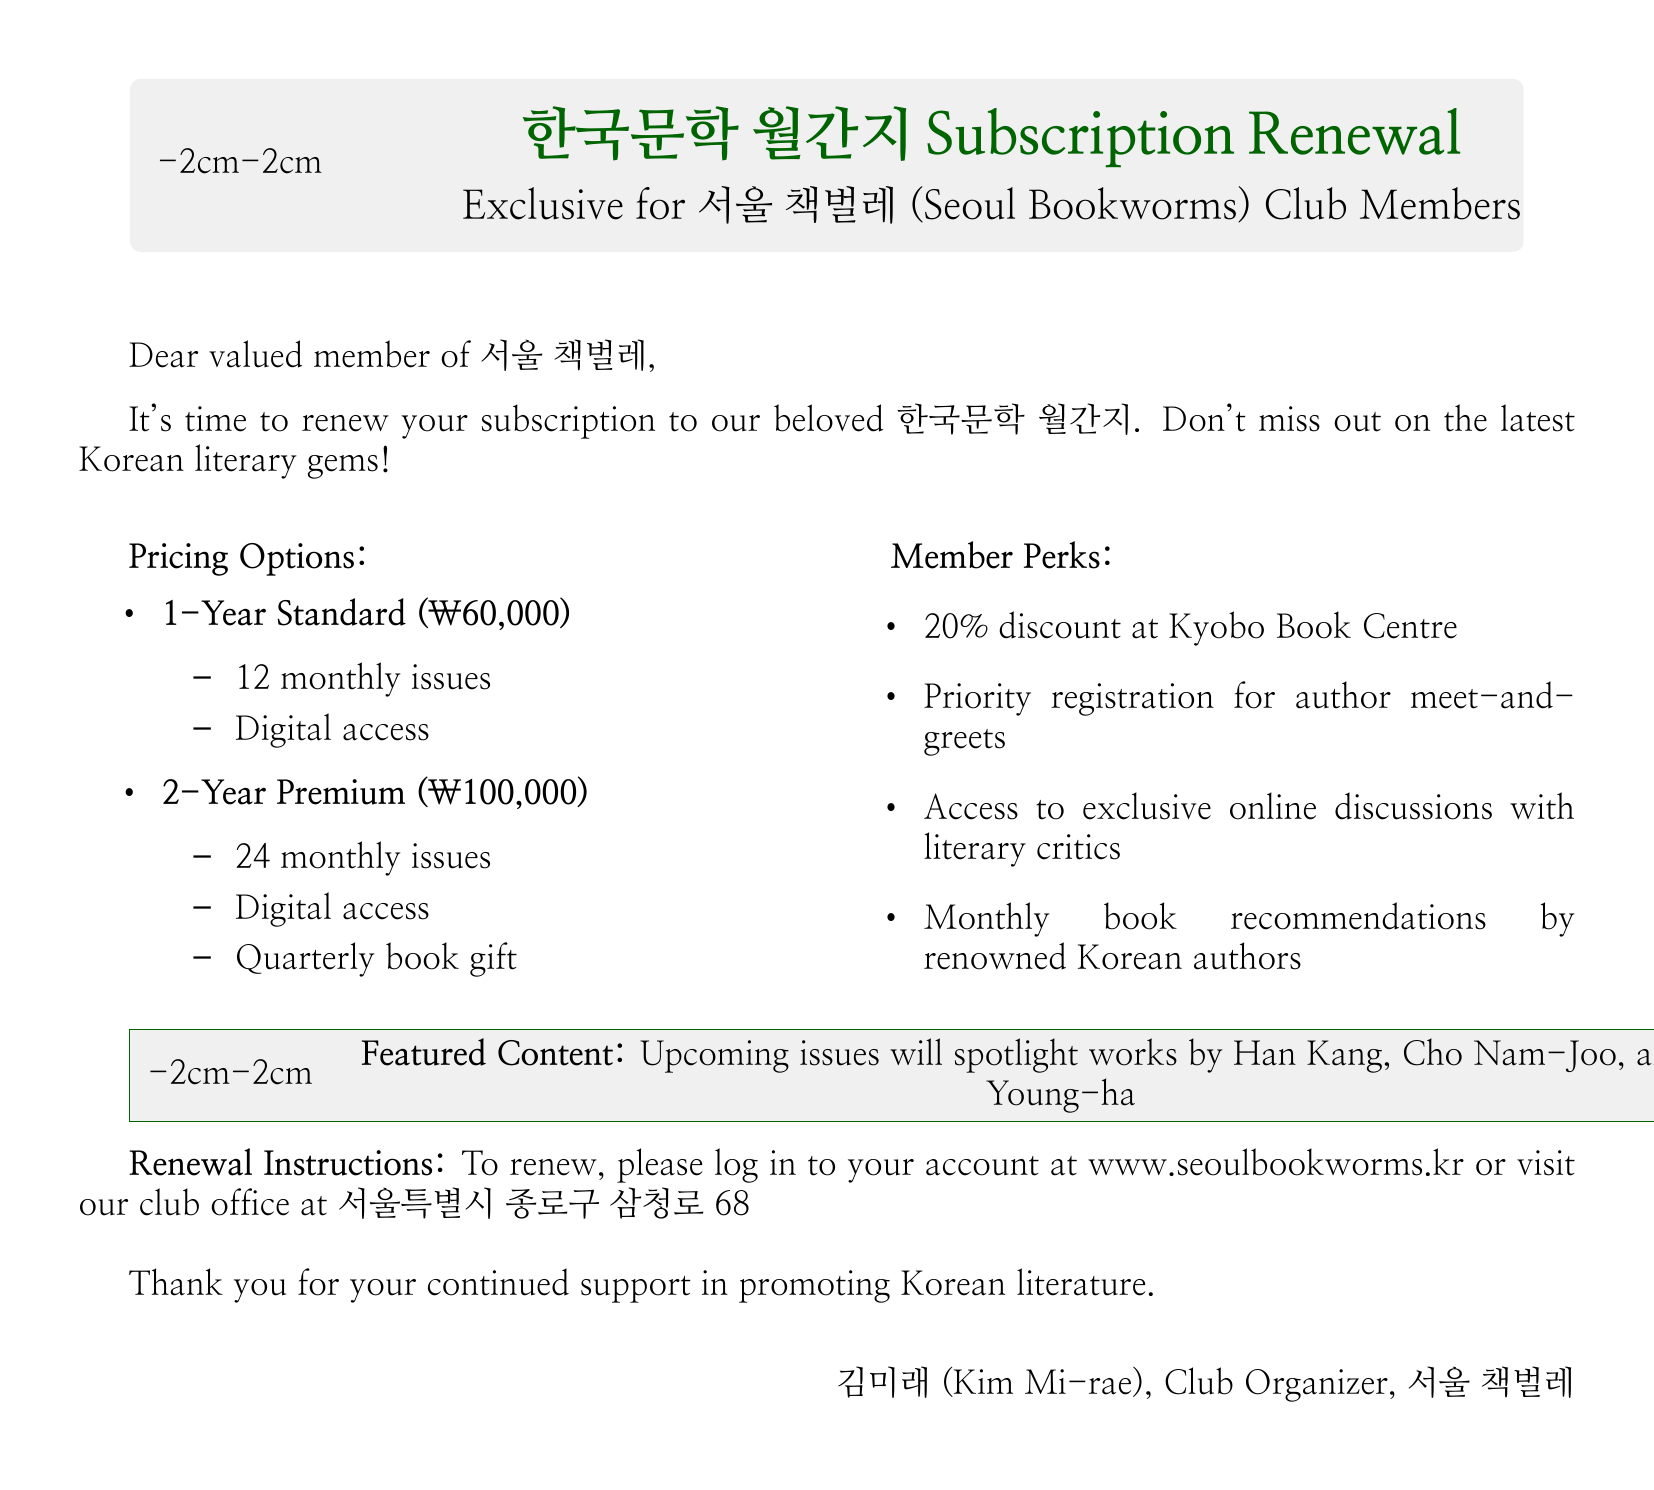What is the title of the magazine? The title is stated prominently at the beginning of the document.
Answer: 한국문학 월간지 What is the price of the 1-Year Standard plan? The pricing options section lists the prices for each plan.
Answer: ₩60,000 How many monthly issues does the 2-Year Premium plan include? The features of the 2-Year Premium plan indicate the number of issues included.
Answer: 24 monthly issues What discount do members receive at Kyobo Book Centre? The member perks section specifies the discount percentage for members.
Answer: 20% Who are some of the authors spotlighted in upcoming issues? The featured content section highlights specific authors whose works will be included.
Answer: Han Kang, Cho Nam-Joo, and Kim Young-ha What must a member do to renew their subscription? The renewal instructions section details the steps a member needs to take to renew.
Answer: Log in to your account or visit the club office How long is the 2-Year Premium plan? The name of the plan indicates its duration.
Answer: 2 years What is the name of the book club? The greeting and the title of the document mention the name of the book club.
Answer: 서울 책벌레 